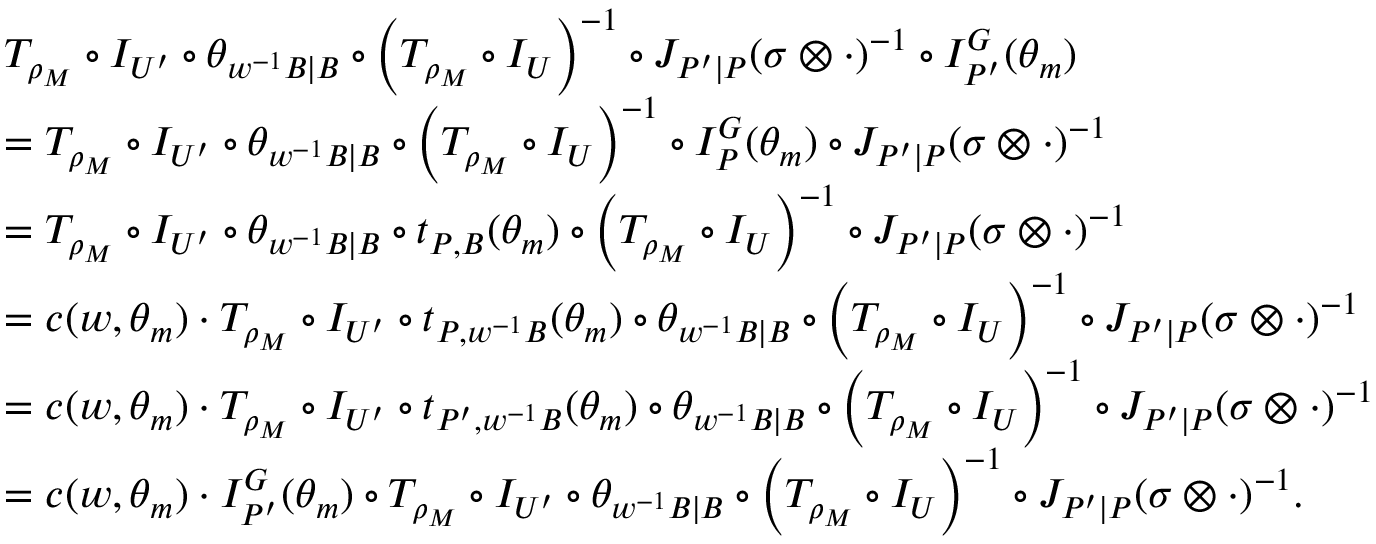<formula> <loc_0><loc_0><loc_500><loc_500>\begin{array} { r l } & { T _ { \rho _ { M } } \circ I _ { U ^ { \prime } } \circ \theta _ { w ^ { - 1 } B | B } \circ \left ( T _ { \rho _ { M } } \circ I _ { U } \right ) ^ { - 1 } \circ J _ { P ^ { \prime } | P } ( \sigma \otimes \cdot ) ^ { - 1 } \circ I _ { P ^ { \prime } } ^ { G } ( \theta _ { m } ) } \\ & { = T _ { \rho _ { M } } \circ I _ { U ^ { \prime } } \circ \theta _ { w ^ { - 1 } B | B } \circ \left ( T _ { \rho _ { M } } \circ I _ { U } \right ) ^ { - 1 } \circ I _ { P } ^ { G } ( \theta _ { m } ) \circ J _ { P ^ { \prime } | P } ( \sigma \otimes \cdot ) ^ { - 1 } } \\ & { = T _ { \rho _ { M } } \circ I _ { U ^ { \prime } } \circ \theta _ { w ^ { - 1 } B | B } \circ t _ { P , B } ( \theta _ { m } ) \circ \left ( T _ { \rho _ { M } } \circ I _ { U } \right ) ^ { - 1 } \circ J _ { P ^ { \prime } | P } ( \sigma \otimes \cdot ) ^ { - 1 } } \\ & { = c ( w , \theta _ { m } ) \cdot T _ { \rho _ { M } } \circ I _ { U ^ { \prime } } \circ t _ { P , w ^ { - 1 } B } ( \theta _ { m } ) \circ \theta _ { w ^ { - 1 } B | B } \circ \left ( T _ { \rho _ { M } } \circ I _ { U } \right ) ^ { - 1 } \circ J _ { P ^ { \prime } | P } ( \sigma \otimes \cdot ) ^ { - 1 } } \\ & { = c ( w , \theta _ { m } ) \cdot T _ { \rho _ { M } } \circ I _ { U ^ { \prime } } \circ t _ { P ^ { \prime } , w ^ { - 1 } B } ( \theta _ { m } ) \circ \theta _ { w ^ { - 1 } B | B } \circ \left ( T _ { \rho _ { M } } \circ I _ { U } \right ) ^ { - 1 } \circ J _ { P ^ { \prime } | P } ( \sigma \otimes \cdot ) ^ { - 1 } } \\ & { = c ( w , \theta _ { m } ) \cdot I _ { P ^ { \prime } } ^ { G } ( \theta _ { m } ) \circ T _ { \rho _ { M } } \circ I _ { U ^ { \prime } } \circ \theta _ { w ^ { - 1 } B | B } \circ \left ( T _ { \rho _ { M } } \circ I _ { U } \right ) ^ { - 1 } \circ J _ { P ^ { \prime } | P } ( \sigma \otimes \cdot ) ^ { - 1 } . } \end{array}</formula> 